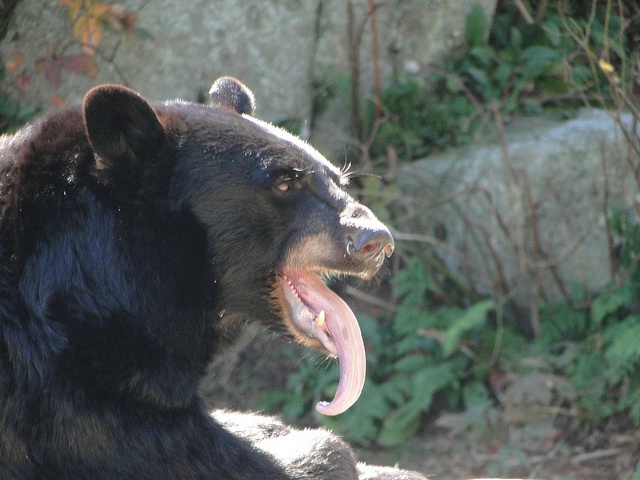Describe the objects in this image and their specific colors. I can see a bear in darkgreen, black, gray, and white tones in this image. 